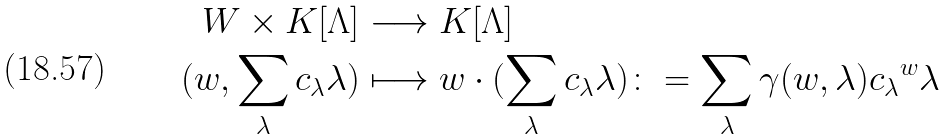<formula> <loc_0><loc_0><loc_500><loc_500>W \times K [ \Lambda ] & \longrightarrow K [ \Lambda ] \\ ( w , \sum _ { \lambda } c _ { \lambda } \lambda ) & \longmapsto w \cdot ( \sum _ { \lambda } c _ { \lambda } \lambda ) \colon = \sum _ { \lambda } \gamma ( w , \lambda ) c _ { \lambda } { ^ { w } \lambda }</formula> 